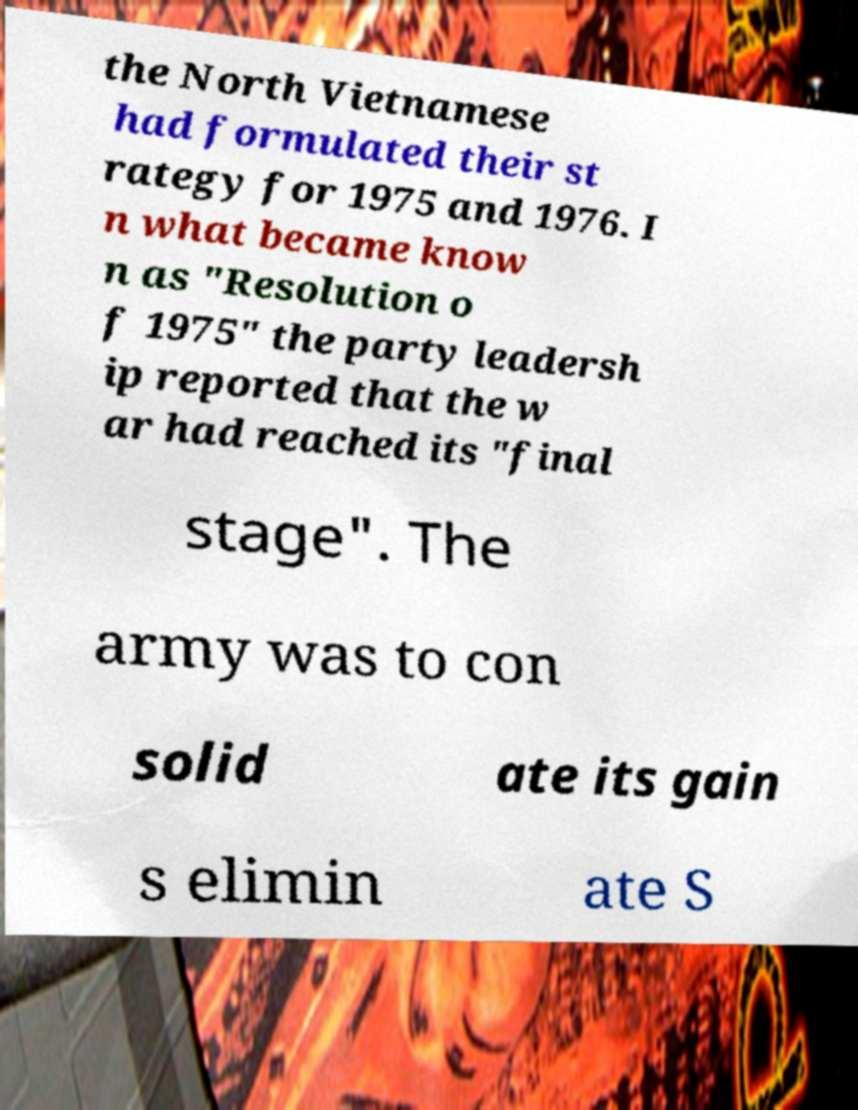Please identify and transcribe the text found in this image. the North Vietnamese had formulated their st rategy for 1975 and 1976. I n what became know n as "Resolution o f 1975" the party leadersh ip reported that the w ar had reached its "final stage". The army was to con solid ate its gain s elimin ate S 